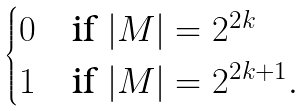<formula> <loc_0><loc_0><loc_500><loc_500>\begin{cases} 0 & \text {if $|M|= 2^{2k}$} \\ 1 & \text {if $|M|= 2^{2k+1}$} . \end{cases}</formula> 